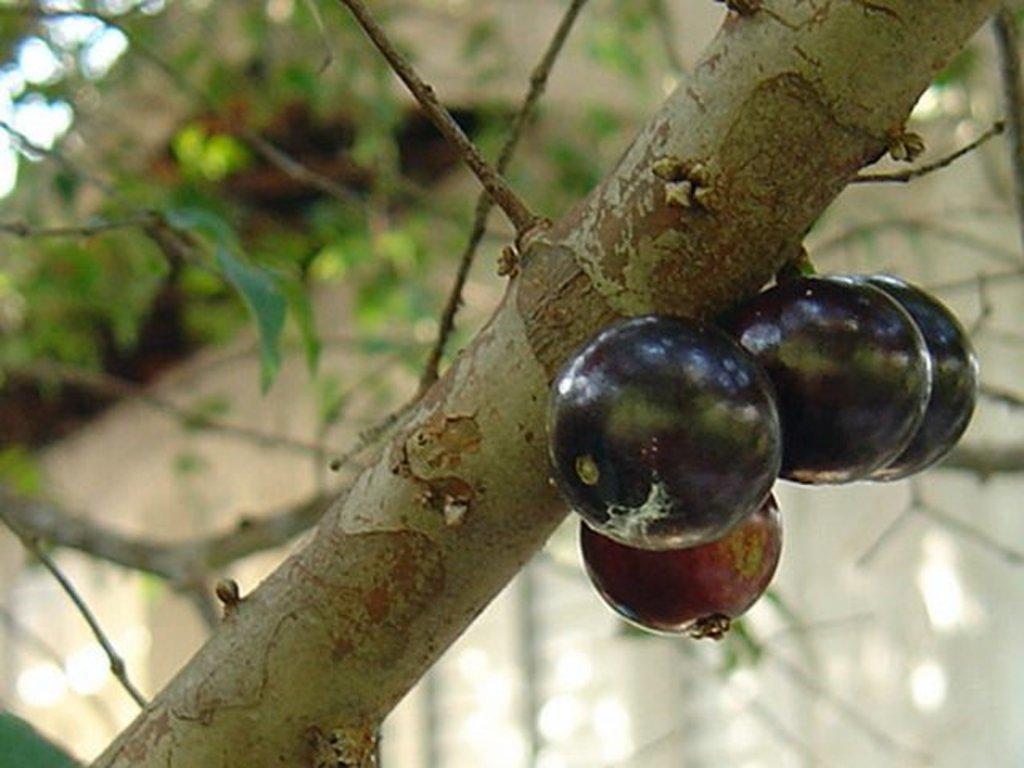Could you give a brief overview of what you see in this image? In this picture I can see there is a tree and it has few fruits attached to the branch and in the backdrop there are many other branches and there is a white surface in the backdrop. 